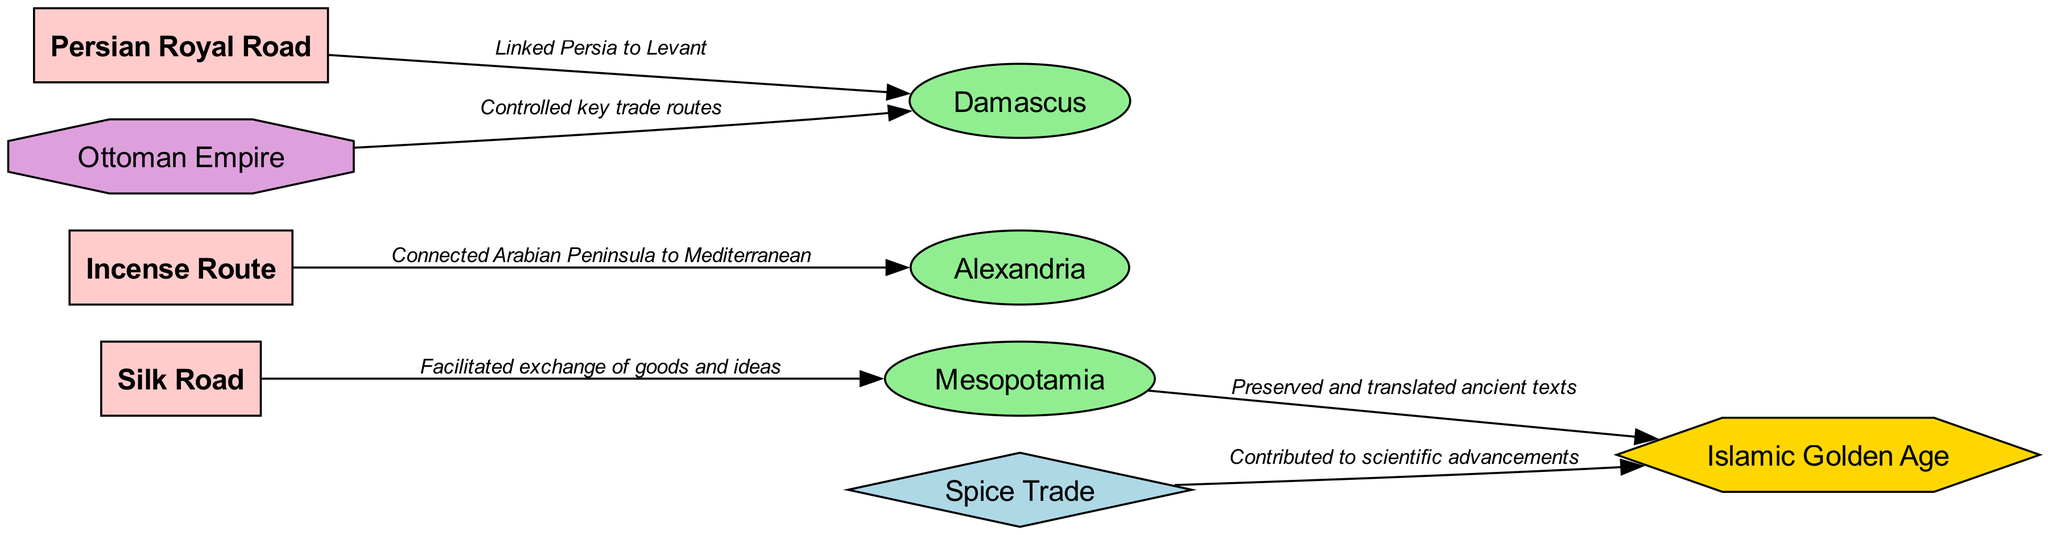What is the total number of nodes in the diagram? The diagram contains a total of 9 nodes, which consist of both trade routes and cultural hubs along with other categories. I counted each node listed in the data, and the final count is 9.
Answer: 9 Which cultural hub is directly linked to the Silk Road? The Silk Road is connected to the cultural hub of Mesopotamia, indicated by the edge labeled "Facilitated exchange of goods and ideas." I identified the source and target nodes for this edge, finding that Mesopotamia corresponds to the target.
Answer: Mesopotamia How many major trade routes are shown in the diagram? There are 3 major trade routes represented in the diagram, specifically, the Silk Road, Incense Route, and Persian Royal Road. I identified each node of type "Major Trade Route" and counted them.
Answer: 3 What cultural period is connected to the Spice Trade? The Spice Trade is linked to the Islamic Golden Age, as shown by the edge labeled "Contributed to scientific advancements." I traced the edge from the Spice Trade node to the cultural period node to find this information.
Answer: Islamic Golden Age Which political entity controlled key trade routes? The Ottoman Empire is identified as the political entity that controlled key trade routes, indicated by the edge linking it to Damascus and labeled "Controlled key trade routes." I reviewed the edge data and confirmed the political entity's connection.
Answer: Ottoman Empire What is the relationship between Mesopotamia and the Islamic Golden Age? Mesopotamia contributed to the preservation and translation of ancient texts during the Islamic Golden Age, as noted in the edge labeled "Preserved and translated ancient texts." I followed the edge in the diagram to explain this relationship.
Answer: Preserved and translated ancient texts Identify the hub that connects the Incense Route. Alexandria is directly associated with the Incense Route, shown by the edge labeled "Connected Arabian Peninsula to Mediterranean." I traced the edge from the Incense Route node to identify the cultural hub it connects to.
Answer: Alexandria Which trade route linked Persia to the Levant? The Persian Royal Road is the trade route that connected Persia to the Levant, as indicated by the edge labeled "Linked Persia to Levant." By identifying this specific edge's source and target, I determined the correct route.
Answer: Persian Royal Road How does the diagram categorize the Spice Trade? In the diagram, the Spice Trade is categorized as a Commodity Exchange, as indicated by its node type in the data. I looked at the node listing to find the relevant classification for the Spice Trade.
Answer: Commodity Exchange 